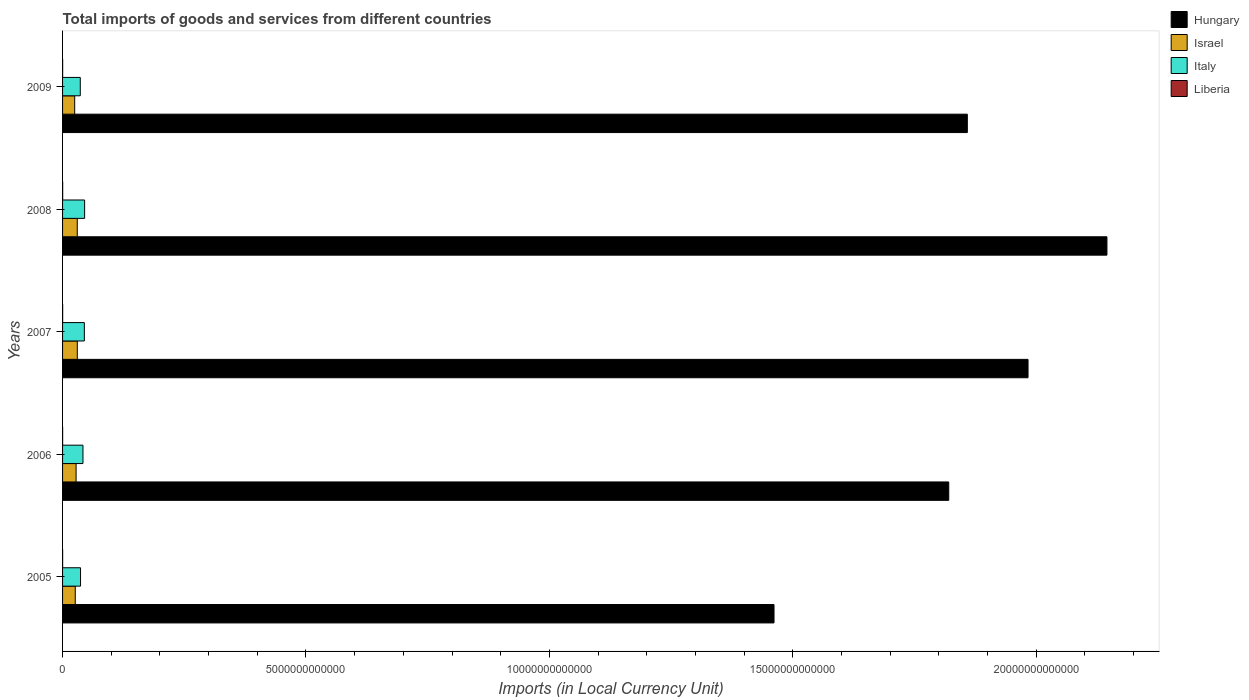How many different coloured bars are there?
Offer a very short reply. 4. How many groups of bars are there?
Provide a short and direct response. 5. Are the number of bars per tick equal to the number of legend labels?
Ensure brevity in your answer.  Yes. What is the label of the 5th group of bars from the top?
Your answer should be compact. 2005. What is the Amount of goods and services imports in Italy in 2005?
Offer a very short reply. 3.69e+11. Across all years, what is the maximum Amount of goods and services imports in Italy?
Provide a short and direct response. 4.53e+11. Across all years, what is the minimum Amount of goods and services imports in Italy?
Provide a succinct answer. 3.64e+11. In which year was the Amount of goods and services imports in Liberia minimum?
Provide a short and direct response. 2005. What is the total Amount of goods and services imports in Italy in the graph?
Your response must be concise. 2.05e+12. What is the difference between the Amount of goods and services imports in Hungary in 2006 and that in 2007?
Your answer should be compact. -1.63e+12. What is the difference between the Amount of goods and services imports in Italy in 2006 and the Amount of goods and services imports in Israel in 2008?
Give a very brief answer. 1.17e+11. What is the average Amount of goods and services imports in Israel per year?
Provide a short and direct response. 2.79e+11. In the year 2007, what is the difference between the Amount of goods and services imports in Hungary and Amount of goods and services imports in Israel?
Provide a short and direct response. 1.95e+13. What is the ratio of the Amount of goods and services imports in Liberia in 2008 to that in 2009?
Offer a terse response. 1.24. Is the Amount of goods and services imports in Liberia in 2005 less than that in 2007?
Provide a short and direct response. Yes. What is the difference between the highest and the second highest Amount of goods and services imports in Liberia?
Ensure brevity in your answer.  3.51e+08. What is the difference between the highest and the lowest Amount of goods and services imports in Israel?
Provide a succinct answer. 5.39e+1. Is the sum of the Amount of goods and services imports in Italy in 2006 and 2009 greater than the maximum Amount of goods and services imports in Liberia across all years?
Your response must be concise. Yes. What does the 1st bar from the top in 2007 represents?
Your answer should be very brief. Liberia. What does the 4th bar from the bottom in 2007 represents?
Your response must be concise. Liberia. Is it the case that in every year, the sum of the Amount of goods and services imports in Italy and Amount of goods and services imports in Israel is greater than the Amount of goods and services imports in Liberia?
Your answer should be very brief. Yes. How many bars are there?
Your answer should be compact. 20. Are all the bars in the graph horizontal?
Your answer should be compact. Yes. What is the difference between two consecutive major ticks on the X-axis?
Your answer should be compact. 5.00e+12. Are the values on the major ticks of X-axis written in scientific E-notation?
Offer a very short reply. No. Does the graph contain any zero values?
Give a very brief answer. No. Does the graph contain grids?
Make the answer very short. No. How many legend labels are there?
Offer a terse response. 4. How are the legend labels stacked?
Offer a very short reply. Vertical. What is the title of the graph?
Give a very brief answer. Total imports of goods and services from different countries. Does "Ghana" appear as one of the legend labels in the graph?
Your answer should be compact. No. What is the label or title of the X-axis?
Provide a succinct answer. Imports (in Local Currency Unit). What is the Imports (in Local Currency Unit) of Hungary in 2005?
Offer a terse response. 1.46e+13. What is the Imports (in Local Currency Unit) of Israel in 2005?
Give a very brief answer. 2.61e+11. What is the Imports (in Local Currency Unit) of Italy in 2005?
Make the answer very short. 3.69e+11. What is the Imports (in Local Currency Unit) of Liberia in 2005?
Your answer should be very brief. 1.16e+09. What is the Imports (in Local Currency Unit) of Hungary in 2006?
Provide a short and direct response. 1.82e+13. What is the Imports (in Local Currency Unit) in Israel in 2006?
Give a very brief answer. 2.78e+11. What is the Imports (in Local Currency Unit) of Italy in 2006?
Offer a very short reply. 4.19e+11. What is the Imports (in Local Currency Unit) in Liberia in 2006?
Give a very brief answer. 1.18e+09. What is the Imports (in Local Currency Unit) of Hungary in 2007?
Give a very brief answer. 1.98e+13. What is the Imports (in Local Currency Unit) of Israel in 2007?
Make the answer very short. 3.03e+11. What is the Imports (in Local Currency Unit) of Italy in 2007?
Offer a terse response. 4.47e+11. What is the Imports (in Local Currency Unit) in Liberia in 2007?
Provide a short and direct response. 1.75e+09. What is the Imports (in Local Currency Unit) in Hungary in 2008?
Give a very brief answer. 2.15e+13. What is the Imports (in Local Currency Unit) of Israel in 2008?
Your answer should be very brief. 3.02e+11. What is the Imports (in Local Currency Unit) in Italy in 2008?
Provide a succinct answer. 4.53e+11. What is the Imports (in Local Currency Unit) of Liberia in 2008?
Offer a very short reply. 2.10e+09. What is the Imports (in Local Currency Unit) in Hungary in 2009?
Provide a short and direct response. 1.86e+13. What is the Imports (in Local Currency Unit) in Israel in 2009?
Keep it short and to the point. 2.49e+11. What is the Imports (in Local Currency Unit) of Italy in 2009?
Ensure brevity in your answer.  3.64e+11. What is the Imports (in Local Currency Unit) of Liberia in 2009?
Give a very brief answer. 1.69e+09. Across all years, what is the maximum Imports (in Local Currency Unit) in Hungary?
Your answer should be compact. 2.15e+13. Across all years, what is the maximum Imports (in Local Currency Unit) in Israel?
Give a very brief answer. 3.03e+11. Across all years, what is the maximum Imports (in Local Currency Unit) of Italy?
Ensure brevity in your answer.  4.53e+11. Across all years, what is the maximum Imports (in Local Currency Unit) in Liberia?
Your answer should be compact. 2.10e+09. Across all years, what is the minimum Imports (in Local Currency Unit) in Hungary?
Your answer should be very brief. 1.46e+13. Across all years, what is the minimum Imports (in Local Currency Unit) in Israel?
Provide a succinct answer. 2.49e+11. Across all years, what is the minimum Imports (in Local Currency Unit) in Italy?
Offer a terse response. 3.64e+11. Across all years, what is the minimum Imports (in Local Currency Unit) in Liberia?
Make the answer very short. 1.16e+09. What is the total Imports (in Local Currency Unit) of Hungary in the graph?
Give a very brief answer. 9.27e+13. What is the total Imports (in Local Currency Unit) in Israel in the graph?
Make the answer very short. 1.39e+12. What is the total Imports (in Local Currency Unit) of Italy in the graph?
Your answer should be compact. 2.05e+12. What is the total Imports (in Local Currency Unit) in Liberia in the graph?
Give a very brief answer. 7.88e+09. What is the difference between the Imports (in Local Currency Unit) of Hungary in 2005 and that in 2006?
Your answer should be very brief. -3.59e+12. What is the difference between the Imports (in Local Currency Unit) of Israel in 2005 and that in 2006?
Offer a very short reply. -1.70e+1. What is the difference between the Imports (in Local Currency Unit) in Italy in 2005 and that in 2006?
Your answer should be very brief. -5.02e+1. What is the difference between the Imports (in Local Currency Unit) in Liberia in 2005 and that in 2006?
Keep it short and to the point. -1.40e+07. What is the difference between the Imports (in Local Currency Unit) of Hungary in 2005 and that in 2007?
Ensure brevity in your answer.  -5.22e+12. What is the difference between the Imports (in Local Currency Unit) in Israel in 2005 and that in 2007?
Offer a very short reply. -4.20e+1. What is the difference between the Imports (in Local Currency Unit) in Italy in 2005 and that in 2007?
Provide a succinct answer. -7.83e+1. What is the difference between the Imports (in Local Currency Unit) of Liberia in 2005 and that in 2007?
Provide a short and direct response. -5.85e+08. What is the difference between the Imports (in Local Currency Unit) of Hungary in 2005 and that in 2008?
Provide a succinct answer. -6.84e+12. What is the difference between the Imports (in Local Currency Unit) in Israel in 2005 and that in 2008?
Your answer should be very brief. -4.10e+1. What is the difference between the Imports (in Local Currency Unit) in Italy in 2005 and that in 2008?
Your answer should be compact. -8.41e+1. What is the difference between the Imports (in Local Currency Unit) in Liberia in 2005 and that in 2008?
Provide a succinct answer. -9.36e+08. What is the difference between the Imports (in Local Currency Unit) of Hungary in 2005 and that in 2009?
Provide a short and direct response. -3.97e+12. What is the difference between the Imports (in Local Currency Unit) of Israel in 2005 and that in 2009?
Make the answer very short. 1.18e+1. What is the difference between the Imports (in Local Currency Unit) in Italy in 2005 and that in 2009?
Keep it short and to the point. 5.04e+09. What is the difference between the Imports (in Local Currency Unit) of Liberia in 2005 and that in 2009?
Provide a short and direct response. -5.30e+08. What is the difference between the Imports (in Local Currency Unit) of Hungary in 2006 and that in 2007?
Make the answer very short. -1.63e+12. What is the difference between the Imports (in Local Currency Unit) in Israel in 2006 and that in 2007?
Ensure brevity in your answer.  -2.50e+1. What is the difference between the Imports (in Local Currency Unit) of Italy in 2006 and that in 2007?
Provide a succinct answer. -2.82e+1. What is the difference between the Imports (in Local Currency Unit) of Liberia in 2006 and that in 2007?
Your response must be concise. -5.71e+08. What is the difference between the Imports (in Local Currency Unit) in Hungary in 2006 and that in 2008?
Provide a short and direct response. -3.25e+12. What is the difference between the Imports (in Local Currency Unit) in Israel in 2006 and that in 2008?
Provide a succinct answer. -2.40e+1. What is the difference between the Imports (in Local Currency Unit) of Italy in 2006 and that in 2008?
Provide a short and direct response. -3.39e+1. What is the difference between the Imports (in Local Currency Unit) in Liberia in 2006 and that in 2008?
Keep it short and to the point. -9.22e+08. What is the difference between the Imports (in Local Currency Unit) of Hungary in 2006 and that in 2009?
Your answer should be compact. -3.82e+11. What is the difference between the Imports (in Local Currency Unit) in Israel in 2006 and that in 2009?
Provide a succinct answer. 2.88e+1. What is the difference between the Imports (in Local Currency Unit) in Italy in 2006 and that in 2009?
Offer a very short reply. 5.52e+1. What is the difference between the Imports (in Local Currency Unit) in Liberia in 2006 and that in 2009?
Provide a short and direct response. -5.16e+08. What is the difference between the Imports (in Local Currency Unit) in Hungary in 2007 and that in 2008?
Keep it short and to the point. -1.62e+12. What is the difference between the Imports (in Local Currency Unit) of Israel in 2007 and that in 2008?
Give a very brief answer. 1.01e+09. What is the difference between the Imports (in Local Currency Unit) of Italy in 2007 and that in 2008?
Offer a terse response. -5.74e+09. What is the difference between the Imports (in Local Currency Unit) in Liberia in 2007 and that in 2008?
Provide a short and direct response. -3.51e+08. What is the difference between the Imports (in Local Currency Unit) in Hungary in 2007 and that in 2009?
Ensure brevity in your answer.  1.25e+12. What is the difference between the Imports (in Local Currency Unit) of Israel in 2007 and that in 2009?
Give a very brief answer. 5.39e+1. What is the difference between the Imports (in Local Currency Unit) of Italy in 2007 and that in 2009?
Ensure brevity in your answer.  8.34e+1. What is the difference between the Imports (in Local Currency Unit) of Liberia in 2007 and that in 2009?
Your answer should be very brief. 5.50e+07. What is the difference between the Imports (in Local Currency Unit) in Hungary in 2008 and that in 2009?
Your answer should be compact. 2.87e+12. What is the difference between the Imports (in Local Currency Unit) of Israel in 2008 and that in 2009?
Ensure brevity in your answer.  5.28e+1. What is the difference between the Imports (in Local Currency Unit) of Italy in 2008 and that in 2009?
Give a very brief answer. 8.91e+1. What is the difference between the Imports (in Local Currency Unit) in Liberia in 2008 and that in 2009?
Your response must be concise. 4.06e+08. What is the difference between the Imports (in Local Currency Unit) of Hungary in 2005 and the Imports (in Local Currency Unit) of Israel in 2006?
Keep it short and to the point. 1.43e+13. What is the difference between the Imports (in Local Currency Unit) of Hungary in 2005 and the Imports (in Local Currency Unit) of Italy in 2006?
Offer a terse response. 1.42e+13. What is the difference between the Imports (in Local Currency Unit) of Hungary in 2005 and the Imports (in Local Currency Unit) of Liberia in 2006?
Make the answer very short. 1.46e+13. What is the difference between the Imports (in Local Currency Unit) in Israel in 2005 and the Imports (in Local Currency Unit) in Italy in 2006?
Provide a succinct answer. -1.58e+11. What is the difference between the Imports (in Local Currency Unit) in Israel in 2005 and the Imports (in Local Currency Unit) in Liberia in 2006?
Make the answer very short. 2.60e+11. What is the difference between the Imports (in Local Currency Unit) of Italy in 2005 and the Imports (in Local Currency Unit) of Liberia in 2006?
Your answer should be very brief. 3.68e+11. What is the difference between the Imports (in Local Currency Unit) in Hungary in 2005 and the Imports (in Local Currency Unit) in Israel in 2007?
Provide a short and direct response. 1.43e+13. What is the difference between the Imports (in Local Currency Unit) in Hungary in 2005 and the Imports (in Local Currency Unit) in Italy in 2007?
Your answer should be very brief. 1.42e+13. What is the difference between the Imports (in Local Currency Unit) of Hungary in 2005 and the Imports (in Local Currency Unit) of Liberia in 2007?
Provide a short and direct response. 1.46e+13. What is the difference between the Imports (in Local Currency Unit) in Israel in 2005 and the Imports (in Local Currency Unit) in Italy in 2007?
Offer a very short reply. -1.86e+11. What is the difference between the Imports (in Local Currency Unit) in Israel in 2005 and the Imports (in Local Currency Unit) in Liberia in 2007?
Your response must be concise. 2.59e+11. What is the difference between the Imports (in Local Currency Unit) in Italy in 2005 and the Imports (in Local Currency Unit) in Liberia in 2007?
Your answer should be compact. 3.67e+11. What is the difference between the Imports (in Local Currency Unit) of Hungary in 2005 and the Imports (in Local Currency Unit) of Israel in 2008?
Your answer should be very brief. 1.43e+13. What is the difference between the Imports (in Local Currency Unit) of Hungary in 2005 and the Imports (in Local Currency Unit) of Italy in 2008?
Your answer should be compact. 1.42e+13. What is the difference between the Imports (in Local Currency Unit) in Hungary in 2005 and the Imports (in Local Currency Unit) in Liberia in 2008?
Ensure brevity in your answer.  1.46e+13. What is the difference between the Imports (in Local Currency Unit) in Israel in 2005 and the Imports (in Local Currency Unit) in Italy in 2008?
Provide a succinct answer. -1.92e+11. What is the difference between the Imports (in Local Currency Unit) of Israel in 2005 and the Imports (in Local Currency Unit) of Liberia in 2008?
Your answer should be very brief. 2.59e+11. What is the difference between the Imports (in Local Currency Unit) in Italy in 2005 and the Imports (in Local Currency Unit) in Liberia in 2008?
Make the answer very short. 3.67e+11. What is the difference between the Imports (in Local Currency Unit) in Hungary in 2005 and the Imports (in Local Currency Unit) in Israel in 2009?
Provide a short and direct response. 1.44e+13. What is the difference between the Imports (in Local Currency Unit) in Hungary in 2005 and the Imports (in Local Currency Unit) in Italy in 2009?
Give a very brief answer. 1.42e+13. What is the difference between the Imports (in Local Currency Unit) in Hungary in 2005 and the Imports (in Local Currency Unit) in Liberia in 2009?
Make the answer very short. 1.46e+13. What is the difference between the Imports (in Local Currency Unit) in Israel in 2005 and the Imports (in Local Currency Unit) in Italy in 2009?
Your response must be concise. -1.03e+11. What is the difference between the Imports (in Local Currency Unit) of Israel in 2005 and the Imports (in Local Currency Unit) of Liberia in 2009?
Keep it short and to the point. 2.59e+11. What is the difference between the Imports (in Local Currency Unit) in Italy in 2005 and the Imports (in Local Currency Unit) in Liberia in 2009?
Make the answer very short. 3.67e+11. What is the difference between the Imports (in Local Currency Unit) of Hungary in 2006 and the Imports (in Local Currency Unit) of Israel in 2007?
Provide a succinct answer. 1.79e+13. What is the difference between the Imports (in Local Currency Unit) of Hungary in 2006 and the Imports (in Local Currency Unit) of Italy in 2007?
Offer a very short reply. 1.78e+13. What is the difference between the Imports (in Local Currency Unit) in Hungary in 2006 and the Imports (in Local Currency Unit) in Liberia in 2007?
Provide a short and direct response. 1.82e+13. What is the difference between the Imports (in Local Currency Unit) of Israel in 2006 and the Imports (in Local Currency Unit) of Italy in 2007?
Give a very brief answer. -1.69e+11. What is the difference between the Imports (in Local Currency Unit) in Israel in 2006 and the Imports (in Local Currency Unit) in Liberia in 2007?
Make the answer very short. 2.76e+11. What is the difference between the Imports (in Local Currency Unit) of Italy in 2006 and the Imports (in Local Currency Unit) of Liberia in 2007?
Provide a succinct answer. 4.17e+11. What is the difference between the Imports (in Local Currency Unit) of Hungary in 2006 and the Imports (in Local Currency Unit) of Israel in 2008?
Keep it short and to the point. 1.79e+13. What is the difference between the Imports (in Local Currency Unit) in Hungary in 2006 and the Imports (in Local Currency Unit) in Italy in 2008?
Offer a terse response. 1.77e+13. What is the difference between the Imports (in Local Currency Unit) of Hungary in 2006 and the Imports (in Local Currency Unit) of Liberia in 2008?
Offer a very short reply. 1.82e+13. What is the difference between the Imports (in Local Currency Unit) of Israel in 2006 and the Imports (in Local Currency Unit) of Italy in 2008?
Provide a succinct answer. -1.75e+11. What is the difference between the Imports (in Local Currency Unit) in Israel in 2006 and the Imports (in Local Currency Unit) in Liberia in 2008?
Offer a terse response. 2.76e+11. What is the difference between the Imports (in Local Currency Unit) in Italy in 2006 and the Imports (in Local Currency Unit) in Liberia in 2008?
Offer a terse response. 4.17e+11. What is the difference between the Imports (in Local Currency Unit) in Hungary in 2006 and the Imports (in Local Currency Unit) in Israel in 2009?
Keep it short and to the point. 1.80e+13. What is the difference between the Imports (in Local Currency Unit) in Hungary in 2006 and the Imports (in Local Currency Unit) in Italy in 2009?
Give a very brief answer. 1.78e+13. What is the difference between the Imports (in Local Currency Unit) of Hungary in 2006 and the Imports (in Local Currency Unit) of Liberia in 2009?
Offer a terse response. 1.82e+13. What is the difference between the Imports (in Local Currency Unit) in Israel in 2006 and the Imports (in Local Currency Unit) in Italy in 2009?
Keep it short and to the point. -8.59e+1. What is the difference between the Imports (in Local Currency Unit) in Israel in 2006 and the Imports (in Local Currency Unit) in Liberia in 2009?
Provide a short and direct response. 2.76e+11. What is the difference between the Imports (in Local Currency Unit) in Italy in 2006 and the Imports (in Local Currency Unit) in Liberia in 2009?
Give a very brief answer. 4.17e+11. What is the difference between the Imports (in Local Currency Unit) of Hungary in 2007 and the Imports (in Local Currency Unit) of Israel in 2008?
Your answer should be compact. 1.95e+13. What is the difference between the Imports (in Local Currency Unit) in Hungary in 2007 and the Imports (in Local Currency Unit) in Italy in 2008?
Provide a succinct answer. 1.94e+13. What is the difference between the Imports (in Local Currency Unit) in Hungary in 2007 and the Imports (in Local Currency Unit) in Liberia in 2008?
Your answer should be compact. 1.98e+13. What is the difference between the Imports (in Local Currency Unit) in Israel in 2007 and the Imports (in Local Currency Unit) in Italy in 2008?
Keep it short and to the point. -1.50e+11. What is the difference between the Imports (in Local Currency Unit) in Israel in 2007 and the Imports (in Local Currency Unit) in Liberia in 2008?
Give a very brief answer. 3.01e+11. What is the difference between the Imports (in Local Currency Unit) in Italy in 2007 and the Imports (in Local Currency Unit) in Liberia in 2008?
Your answer should be compact. 4.45e+11. What is the difference between the Imports (in Local Currency Unit) in Hungary in 2007 and the Imports (in Local Currency Unit) in Israel in 2009?
Provide a succinct answer. 1.96e+13. What is the difference between the Imports (in Local Currency Unit) of Hungary in 2007 and the Imports (in Local Currency Unit) of Italy in 2009?
Offer a terse response. 1.95e+13. What is the difference between the Imports (in Local Currency Unit) in Hungary in 2007 and the Imports (in Local Currency Unit) in Liberia in 2009?
Your answer should be compact. 1.98e+13. What is the difference between the Imports (in Local Currency Unit) of Israel in 2007 and the Imports (in Local Currency Unit) of Italy in 2009?
Provide a short and direct response. -6.09e+1. What is the difference between the Imports (in Local Currency Unit) of Israel in 2007 and the Imports (in Local Currency Unit) of Liberia in 2009?
Your answer should be compact. 3.01e+11. What is the difference between the Imports (in Local Currency Unit) in Italy in 2007 and the Imports (in Local Currency Unit) in Liberia in 2009?
Your response must be concise. 4.46e+11. What is the difference between the Imports (in Local Currency Unit) in Hungary in 2008 and the Imports (in Local Currency Unit) in Israel in 2009?
Your answer should be compact. 2.12e+13. What is the difference between the Imports (in Local Currency Unit) of Hungary in 2008 and the Imports (in Local Currency Unit) of Italy in 2009?
Ensure brevity in your answer.  2.11e+13. What is the difference between the Imports (in Local Currency Unit) in Hungary in 2008 and the Imports (in Local Currency Unit) in Liberia in 2009?
Give a very brief answer. 2.15e+13. What is the difference between the Imports (in Local Currency Unit) of Israel in 2008 and the Imports (in Local Currency Unit) of Italy in 2009?
Offer a very short reply. -6.19e+1. What is the difference between the Imports (in Local Currency Unit) of Israel in 2008 and the Imports (in Local Currency Unit) of Liberia in 2009?
Your answer should be compact. 3.00e+11. What is the difference between the Imports (in Local Currency Unit) in Italy in 2008 and the Imports (in Local Currency Unit) in Liberia in 2009?
Provide a succinct answer. 4.51e+11. What is the average Imports (in Local Currency Unit) in Hungary per year?
Provide a short and direct response. 1.85e+13. What is the average Imports (in Local Currency Unit) of Israel per year?
Make the answer very short. 2.79e+11. What is the average Imports (in Local Currency Unit) of Italy per year?
Your response must be concise. 4.10e+11. What is the average Imports (in Local Currency Unit) in Liberia per year?
Make the answer very short. 1.58e+09. In the year 2005, what is the difference between the Imports (in Local Currency Unit) in Hungary and Imports (in Local Currency Unit) in Israel?
Your answer should be very brief. 1.44e+13. In the year 2005, what is the difference between the Imports (in Local Currency Unit) of Hungary and Imports (in Local Currency Unit) of Italy?
Make the answer very short. 1.42e+13. In the year 2005, what is the difference between the Imports (in Local Currency Unit) in Hungary and Imports (in Local Currency Unit) in Liberia?
Make the answer very short. 1.46e+13. In the year 2005, what is the difference between the Imports (in Local Currency Unit) in Israel and Imports (in Local Currency Unit) in Italy?
Your answer should be very brief. -1.08e+11. In the year 2005, what is the difference between the Imports (in Local Currency Unit) in Israel and Imports (in Local Currency Unit) in Liberia?
Provide a succinct answer. 2.60e+11. In the year 2005, what is the difference between the Imports (in Local Currency Unit) in Italy and Imports (in Local Currency Unit) in Liberia?
Make the answer very short. 3.68e+11. In the year 2006, what is the difference between the Imports (in Local Currency Unit) of Hungary and Imports (in Local Currency Unit) of Israel?
Ensure brevity in your answer.  1.79e+13. In the year 2006, what is the difference between the Imports (in Local Currency Unit) in Hungary and Imports (in Local Currency Unit) in Italy?
Keep it short and to the point. 1.78e+13. In the year 2006, what is the difference between the Imports (in Local Currency Unit) of Hungary and Imports (in Local Currency Unit) of Liberia?
Your response must be concise. 1.82e+13. In the year 2006, what is the difference between the Imports (in Local Currency Unit) of Israel and Imports (in Local Currency Unit) of Italy?
Your answer should be compact. -1.41e+11. In the year 2006, what is the difference between the Imports (in Local Currency Unit) in Israel and Imports (in Local Currency Unit) in Liberia?
Give a very brief answer. 2.77e+11. In the year 2006, what is the difference between the Imports (in Local Currency Unit) in Italy and Imports (in Local Currency Unit) in Liberia?
Your answer should be very brief. 4.18e+11. In the year 2007, what is the difference between the Imports (in Local Currency Unit) in Hungary and Imports (in Local Currency Unit) in Israel?
Ensure brevity in your answer.  1.95e+13. In the year 2007, what is the difference between the Imports (in Local Currency Unit) in Hungary and Imports (in Local Currency Unit) in Italy?
Your answer should be compact. 1.94e+13. In the year 2007, what is the difference between the Imports (in Local Currency Unit) in Hungary and Imports (in Local Currency Unit) in Liberia?
Offer a terse response. 1.98e+13. In the year 2007, what is the difference between the Imports (in Local Currency Unit) of Israel and Imports (in Local Currency Unit) of Italy?
Offer a very short reply. -1.44e+11. In the year 2007, what is the difference between the Imports (in Local Currency Unit) of Israel and Imports (in Local Currency Unit) of Liberia?
Make the answer very short. 3.01e+11. In the year 2007, what is the difference between the Imports (in Local Currency Unit) of Italy and Imports (in Local Currency Unit) of Liberia?
Make the answer very short. 4.45e+11. In the year 2008, what is the difference between the Imports (in Local Currency Unit) of Hungary and Imports (in Local Currency Unit) of Israel?
Give a very brief answer. 2.12e+13. In the year 2008, what is the difference between the Imports (in Local Currency Unit) in Hungary and Imports (in Local Currency Unit) in Italy?
Provide a succinct answer. 2.10e+13. In the year 2008, what is the difference between the Imports (in Local Currency Unit) in Hungary and Imports (in Local Currency Unit) in Liberia?
Offer a terse response. 2.14e+13. In the year 2008, what is the difference between the Imports (in Local Currency Unit) in Israel and Imports (in Local Currency Unit) in Italy?
Your response must be concise. -1.51e+11. In the year 2008, what is the difference between the Imports (in Local Currency Unit) of Israel and Imports (in Local Currency Unit) of Liberia?
Give a very brief answer. 3.00e+11. In the year 2008, what is the difference between the Imports (in Local Currency Unit) in Italy and Imports (in Local Currency Unit) in Liberia?
Offer a terse response. 4.51e+11. In the year 2009, what is the difference between the Imports (in Local Currency Unit) in Hungary and Imports (in Local Currency Unit) in Israel?
Your answer should be compact. 1.83e+13. In the year 2009, what is the difference between the Imports (in Local Currency Unit) in Hungary and Imports (in Local Currency Unit) in Italy?
Offer a very short reply. 1.82e+13. In the year 2009, what is the difference between the Imports (in Local Currency Unit) in Hungary and Imports (in Local Currency Unit) in Liberia?
Your answer should be very brief. 1.86e+13. In the year 2009, what is the difference between the Imports (in Local Currency Unit) in Israel and Imports (in Local Currency Unit) in Italy?
Provide a succinct answer. -1.15e+11. In the year 2009, what is the difference between the Imports (in Local Currency Unit) of Israel and Imports (in Local Currency Unit) of Liberia?
Your response must be concise. 2.47e+11. In the year 2009, what is the difference between the Imports (in Local Currency Unit) of Italy and Imports (in Local Currency Unit) of Liberia?
Keep it short and to the point. 3.62e+11. What is the ratio of the Imports (in Local Currency Unit) of Hungary in 2005 to that in 2006?
Ensure brevity in your answer.  0.8. What is the ratio of the Imports (in Local Currency Unit) in Israel in 2005 to that in 2006?
Your answer should be compact. 0.94. What is the ratio of the Imports (in Local Currency Unit) in Italy in 2005 to that in 2006?
Offer a terse response. 0.88. What is the ratio of the Imports (in Local Currency Unit) in Hungary in 2005 to that in 2007?
Ensure brevity in your answer.  0.74. What is the ratio of the Imports (in Local Currency Unit) of Israel in 2005 to that in 2007?
Ensure brevity in your answer.  0.86. What is the ratio of the Imports (in Local Currency Unit) of Italy in 2005 to that in 2007?
Keep it short and to the point. 0.82. What is the ratio of the Imports (in Local Currency Unit) of Liberia in 2005 to that in 2007?
Give a very brief answer. 0.67. What is the ratio of the Imports (in Local Currency Unit) of Hungary in 2005 to that in 2008?
Offer a very short reply. 0.68. What is the ratio of the Imports (in Local Currency Unit) in Israel in 2005 to that in 2008?
Keep it short and to the point. 0.86. What is the ratio of the Imports (in Local Currency Unit) of Italy in 2005 to that in 2008?
Provide a short and direct response. 0.81. What is the ratio of the Imports (in Local Currency Unit) of Liberia in 2005 to that in 2008?
Give a very brief answer. 0.55. What is the ratio of the Imports (in Local Currency Unit) in Hungary in 2005 to that in 2009?
Provide a succinct answer. 0.79. What is the ratio of the Imports (in Local Currency Unit) in Israel in 2005 to that in 2009?
Offer a terse response. 1.05. What is the ratio of the Imports (in Local Currency Unit) of Italy in 2005 to that in 2009?
Offer a very short reply. 1.01. What is the ratio of the Imports (in Local Currency Unit) of Liberia in 2005 to that in 2009?
Provide a short and direct response. 0.69. What is the ratio of the Imports (in Local Currency Unit) in Hungary in 2006 to that in 2007?
Offer a very short reply. 0.92. What is the ratio of the Imports (in Local Currency Unit) of Israel in 2006 to that in 2007?
Make the answer very short. 0.92. What is the ratio of the Imports (in Local Currency Unit) of Italy in 2006 to that in 2007?
Make the answer very short. 0.94. What is the ratio of the Imports (in Local Currency Unit) of Liberia in 2006 to that in 2007?
Give a very brief answer. 0.67. What is the ratio of the Imports (in Local Currency Unit) in Hungary in 2006 to that in 2008?
Make the answer very short. 0.85. What is the ratio of the Imports (in Local Currency Unit) in Israel in 2006 to that in 2008?
Keep it short and to the point. 0.92. What is the ratio of the Imports (in Local Currency Unit) in Italy in 2006 to that in 2008?
Ensure brevity in your answer.  0.93. What is the ratio of the Imports (in Local Currency Unit) of Liberia in 2006 to that in 2008?
Make the answer very short. 0.56. What is the ratio of the Imports (in Local Currency Unit) in Hungary in 2006 to that in 2009?
Provide a short and direct response. 0.98. What is the ratio of the Imports (in Local Currency Unit) in Israel in 2006 to that in 2009?
Provide a short and direct response. 1.12. What is the ratio of the Imports (in Local Currency Unit) of Italy in 2006 to that in 2009?
Make the answer very short. 1.15. What is the ratio of the Imports (in Local Currency Unit) in Liberia in 2006 to that in 2009?
Keep it short and to the point. 0.69. What is the ratio of the Imports (in Local Currency Unit) in Hungary in 2007 to that in 2008?
Offer a very short reply. 0.92. What is the ratio of the Imports (in Local Currency Unit) in Israel in 2007 to that in 2008?
Your answer should be compact. 1. What is the ratio of the Imports (in Local Currency Unit) in Italy in 2007 to that in 2008?
Keep it short and to the point. 0.99. What is the ratio of the Imports (in Local Currency Unit) of Liberia in 2007 to that in 2008?
Ensure brevity in your answer.  0.83. What is the ratio of the Imports (in Local Currency Unit) in Hungary in 2007 to that in 2009?
Offer a very short reply. 1.07. What is the ratio of the Imports (in Local Currency Unit) in Israel in 2007 to that in 2009?
Give a very brief answer. 1.22. What is the ratio of the Imports (in Local Currency Unit) in Italy in 2007 to that in 2009?
Give a very brief answer. 1.23. What is the ratio of the Imports (in Local Currency Unit) in Liberia in 2007 to that in 2009?
Give a very brief answer. 1.03. What is the ratio of the Imports (in Local Currency Unit) in Hungary in 2008 to that in 2009?
Provide a short and direct response. 1.15. What is the ratio of the Imports (in Local Currency Unit) of Israel in 2008 to that in 2009?
Keep it short and to the point. 1.21. What is the ratio of the Imports (in Local Currency Unit) in Italy in 2008 to that in 2009?
Give a very brief answer. 1.25. What is the ratio of the Imports (in Local Currency Unit) of Liberia in 2008 to that in 2009?
Provide a short and direct response. 1.24. What is the difference between the highest and the second highest Imports (in Local Currency Unit) of Hungary?
Your answer should be very brief. 1.62e+12. What is the difference between the highest and the second highest Imports (in Local Currency Unit) of Israel?
Keep it short and to the point. 1.01e+09. What is the difference between the highest and the second highest Imports (in Local Currency Unit) of Italy?
Keep it short and to the point. 5.74e+09. What is the difference between the highest and the second highest Imports (in Local Currency Unit) of Liberia?
Your answer should be compact. 3.51e+08. What is the difference between the highest and the lowest Imports (in Local Currency Unit) of Hungary?
Provide a succinct answer. 6.84e+12. What is the difference between the highest and the lowest Imports (in Local Currency Unit) in Israel?
Provide a short and direct response. 5.39e+1. What is the difference between the highest and the lowest Imports (in Local Currency Unit) in Italy?
Make the answer very short. 8.91e+1. What is the difference between the highest and the lowest Imports (in Local Currency Unit) in Liberia?
Provide a succinct answer. 9.36e+08. 